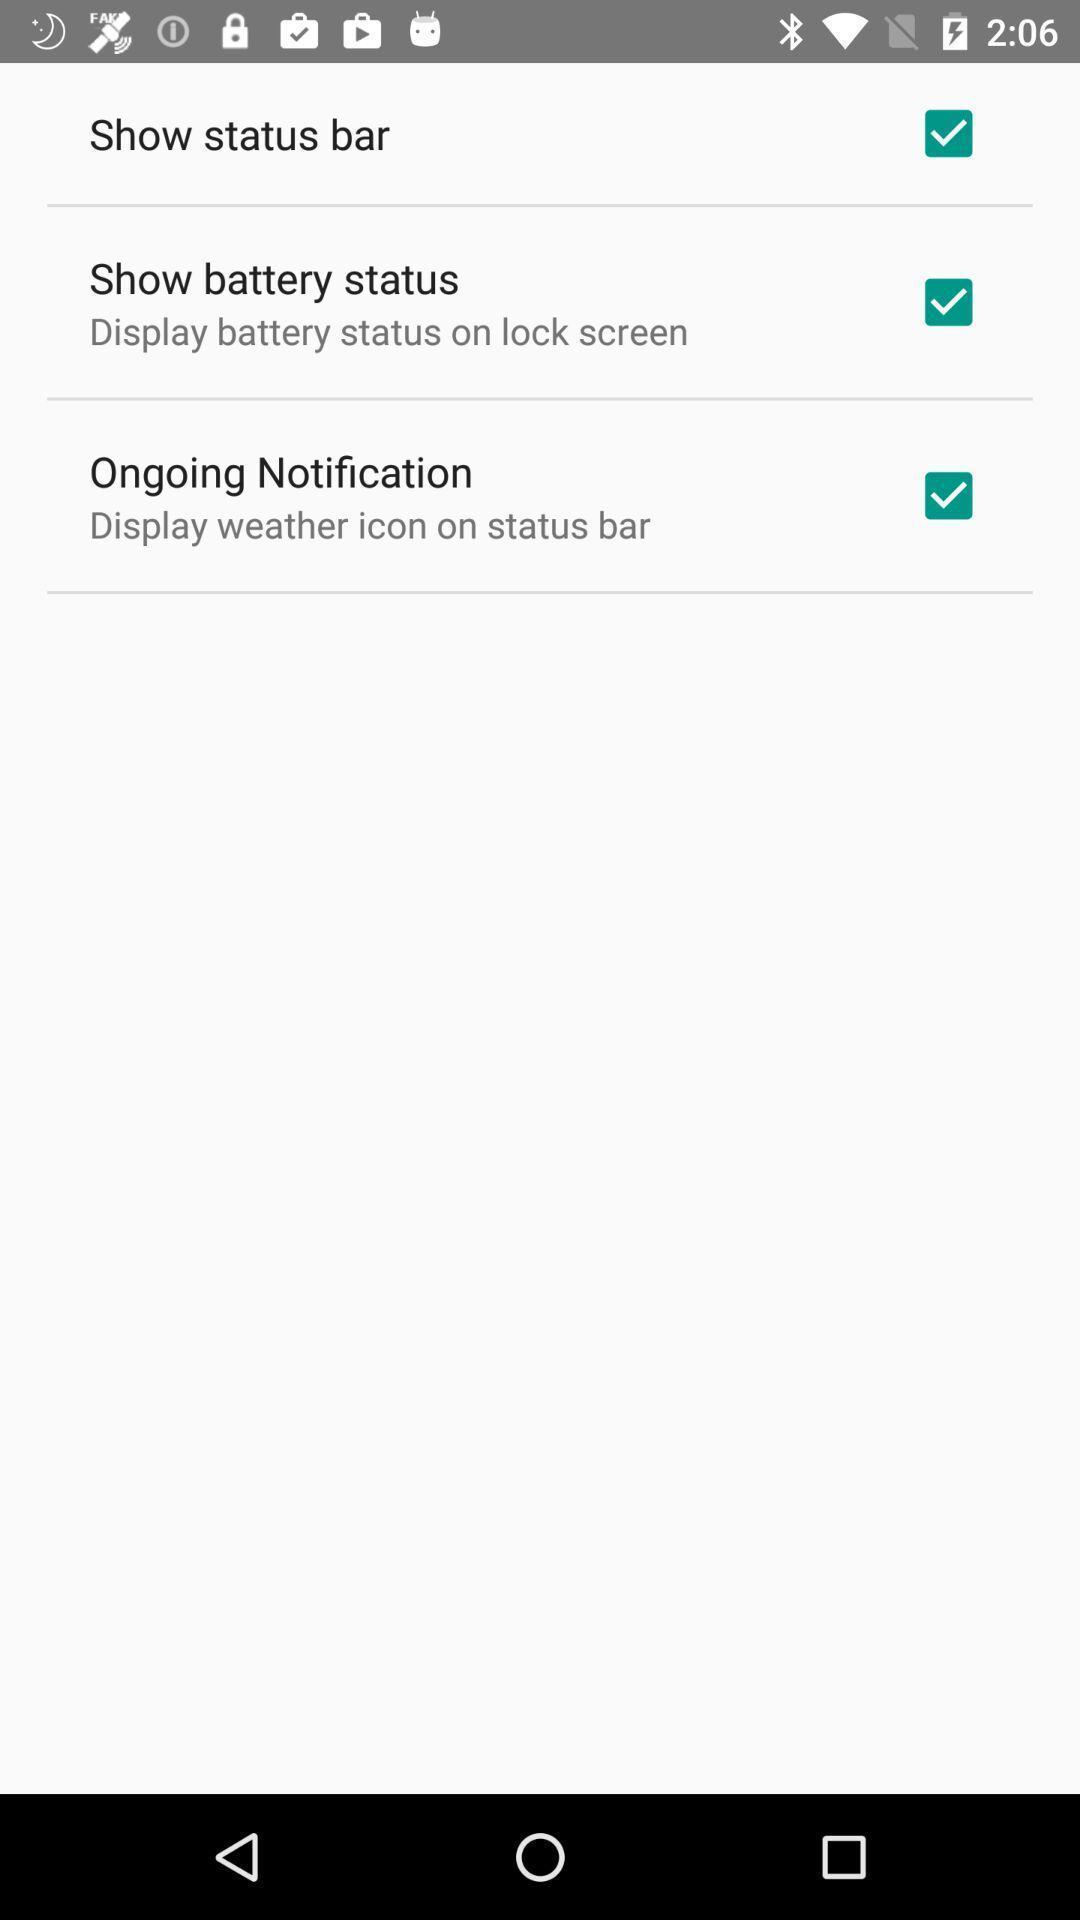Explain the elements present in this screenshot. Status bar battery status and notification options displayed. 